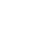Convert code to text. <code><loc_0><loc_0><loc_500><loc_500><_SQL_>










</code> 